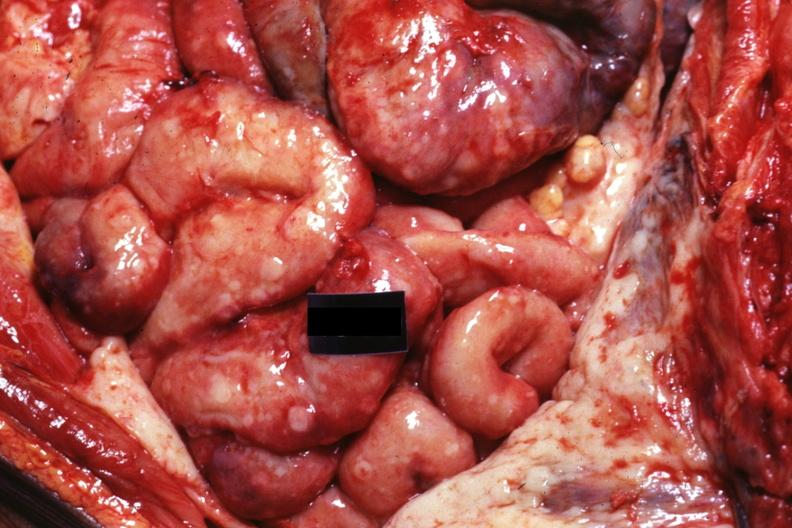s this present?
Answer the question using a single word or phrase. No 